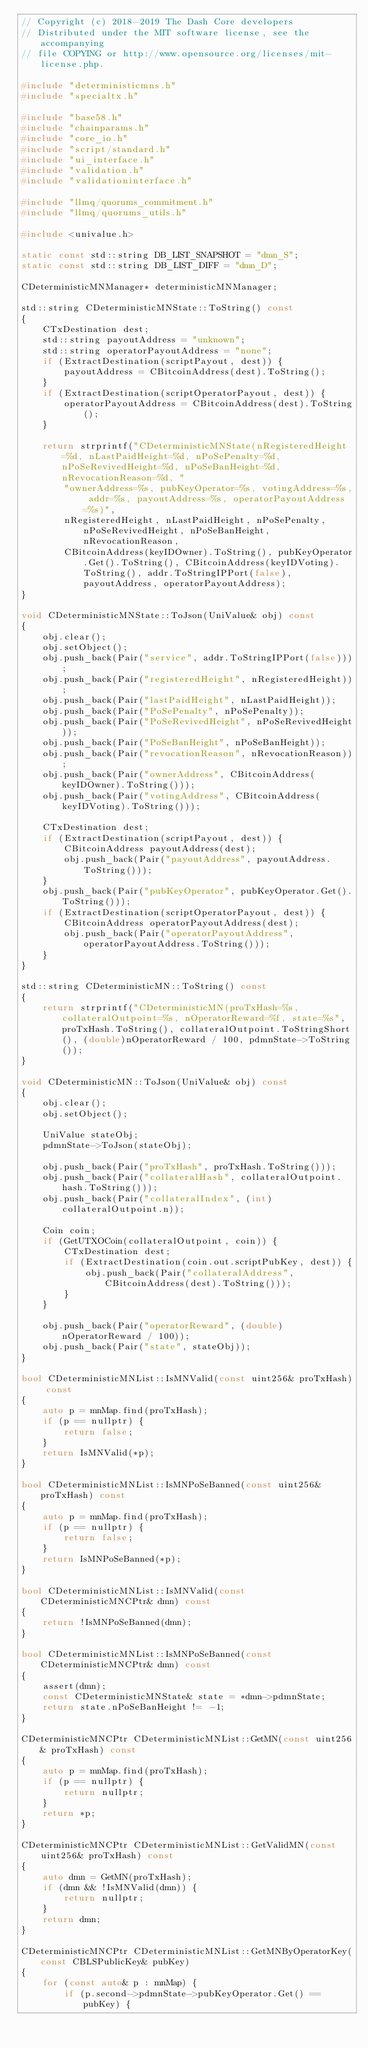<code> <loc_0><loc_0><loc_500><loc_500><_C++_>// Copyright (c) 2018-2019 The Dash Core developers
// Distributed under the MIT software license, see the accompanying
// file COPYING or http://www.opensource.org/licenses/mit-license.php.

#include "deterministicmns.h"
#include "specialtx.h"

#include "base58.h"
#include "chainparams.h"
#include "core_io.h"
#include "script/standard.h"
#include "ui_interface.h"
#include "validation.h"
#include "validationinterface.h"

#include "llmq/quorums_commitment.h"
#include "llmq/quorums_utils.h"

#include <univalue.h>

static const std::string DB_LIST_SNAPSHOT = "dmn_S";
static const std::string DB_LIST_DIFF = "dmn_D";

CDeterministicMNManager* deterministicMNManager;

std::string CDeterministicMNState::ToString() const
{
    CTxDestination dest;
    std::string payoutAddress = "unknown";
    std::string operatorPayoutAddress = "none";
    if (ExtractDestination(scriptPayout, dest)) {
        payoutAddress = CBitcoinAddress(dest).ToString();
    }
    if (ExtractDestination(scriptOperatorPayout, dest)) {
        operatorPayoutAddress = CBitcoinAddress(dest).ToString();
    }

    return strprintf("CDeterministicMNState(nRegisteredHeight=%d, nLastPaidHeight=%d, nPoSePenalty=%d, nPoSeRevivedHeight=%d, nPoSeBanHeight=%d, nRevocationReason=%d, "
        "ownerAddress=%s, pubKeyOperator=%s, votingAddress=%s, addr=%s, payoutAddress=%s, operatorPayoutAddress=%s)",
        nRegisteredHeight, nLastPaidHeight, nPoSePenalty, nPoSeRevivedHeight, nPoSeBanHeight, nRevocationReason,
        CBitcoinAddress(keyIDOwner).ToString(), pubKeyOperator.Get().ToString(), CBitcoinAddress(keyIDVoting).ToString(), addr.ToStringIPPort(false), payoutAddress, operatorPayoutAddress);
}

void CDeterministicMNState::ToJson(UniValue& obj) const
{
    obj.clear();
    obj.setObject();
    obj.push_back(Pair("service", addr.ToStringIPPort(false)));
    obj.push_back(Pair("registeredHeight", nRegisteredHeight));
    obj.push_back(Pair("lastPaidHeight", nLastPaidHeight));
    obj.push_back(Pair("PoSePenalty", nPoSePenalty));
    obj.push_back(Pair("PoSeRevivedHeight", nPoSeRevivedHeight));
    obj.push_back(Pair("PoSeBanHeight", nPoSeBanHeight));
    obj.push_back(Pair("revocationReason", nRevocationReason));
    obj.push_back(Pair("ownerAddress", CBitcoinAddress(keyIDOwner).ToString()));
    obj.push_back(Pair("votingAddress", CBitcoinAddress(keyIDVoting).ToString()));

    CTxDestination dest;
    if (ExtractDestination(scriptPayout, dest)) {
        CBitcoinAddress payoutAddress(dest);
        obj.push_back(Pair("payoutAddress", payoutAddress.ToString()));
    }
    obj.push_back(Pair("pubKeyOperator", pubKeyOperator.Get().ToString()));
    if (ExtractDestination(scriptOperatorPayout, dest)) {
        CBitcoinAddress operatorPayoutAddress(dest);
        obj.push_back(Pair("operatorPayoutAddress", operatorPayoutAddress.ToString()));
    }
}

std::string CDeterministicMN::ToString() const
{
    return strprintf("CDeterministicMN(proTxHash=%s, collateralOutpoint=%s, nOperatorReward=%f, state=%s", proTxHash.ToString(), collateralOutpoint.ToStringShort(), (double)nOperatorReward / 100, pdmnState->ToString());
}

void CDeterministicMN::ToJson(UniValue& obj) const
{
    obj.clear();
    obj.setObject();

    UniValue stateObj;
    pdmnState->ToJson(stateObj);

    obj.push_back(Pair("proTxHash", proTxHash.ToString()));
    obj.push_back(Pair("collateralHash", collateralOutpoint.hash.ToString()));
    obj.push_back(Pair("collateralIndex", (int)collateralOutpoint.n));

    Coin coin;
    if (GetUTXOCoin(collateralOutpoint, coin)) {
        CTxDestination dest;
        if (ExtractDestination(coin.out.scriptPubKey, dest)) {
            obj.push_back(Pair("collateralAddress", CBitcoinAddress(dest).ToString()));
        }
    }

    obj.push_back(Pair("operatorReward", (double)nOperatorReward / 100));
    obj.push_back(Pair("state", stateObj));
}

bool CDeterministicMNList::IsMNValid(const uint256& proTxHash) const
{
    auto p = mnMap.find(proTxHash);
    if (p == nullptr) {
        return false;
    }
    return IsMNValid(*p);
}

bool CDeterministicMNList::IsMNPoSeBanned(const uint256& proTxHash) const
{
    auto p = mnMap.find(proTxHash);
    if (p == nullptr) {
        return false;
    }
    return IsMNPoSeBanned(*p);
}

bool CDeterministicMNList::IsMNValid(const CDeterministicMNCPtr& dmn) const
{
    return !IsMNPoSeBanned(dmn);
}

bool CDeterministicMNList::IsMNPoSeBanned(const CDeterministicMNCPtr& dmn) const
{
    assert(dmn);
    const CDeterministicMNState& state = *dmn->pdmnState;
    return state.nPoSeBanHeight != -1;
}

CDeterministicMNCPtr CDeterministicMNList::GetMN(const uint256& proTxHash) const
{
    auto p = mnMap.find(proTxHash);
    if (p == nullptr) {
        return nullptr;
    }
    return *p;
}

CDeterministicMNCPtr CDeterministicMNList::GetValidMN(const uint256& proTxHash) const
{
    auto dmn = GetMN(proTxHash);
    if (dmn && !IsMNValid(dmn)) {
        return nullptr;
    }
    return dmn;
}

CDeterministicMNCPtr CDeterministicMNList::GetMNByOperatorKey(const CBLSPublicKey& pubKey)
{
    for (const auto& p : mnMap) {
        if (p.second->pdmnState->pubKeyOperator.Get() == pubKey) {</code> 